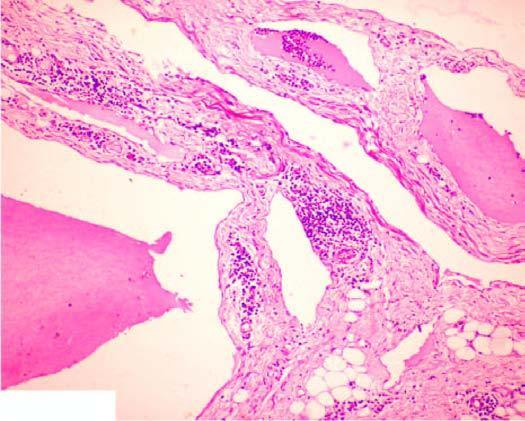what shows scattered collection of lymphocytes?
Answer the question using a single word or phrase. Stroma 